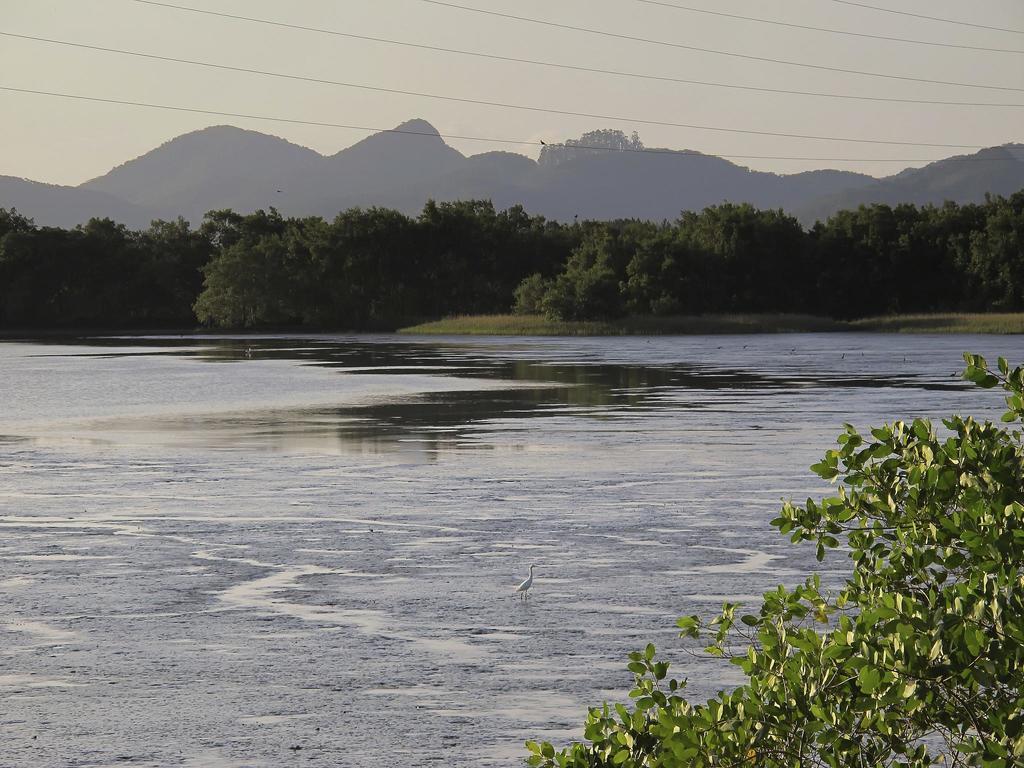In one or two sentences, can you explain what this image depicts? In this image we can see the bird, water, plants, trees, hills and the sky in the background. 